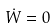<formula> <loc_0><loc_0><loc_500><loc_500>\dot { W } = 0</formula> 